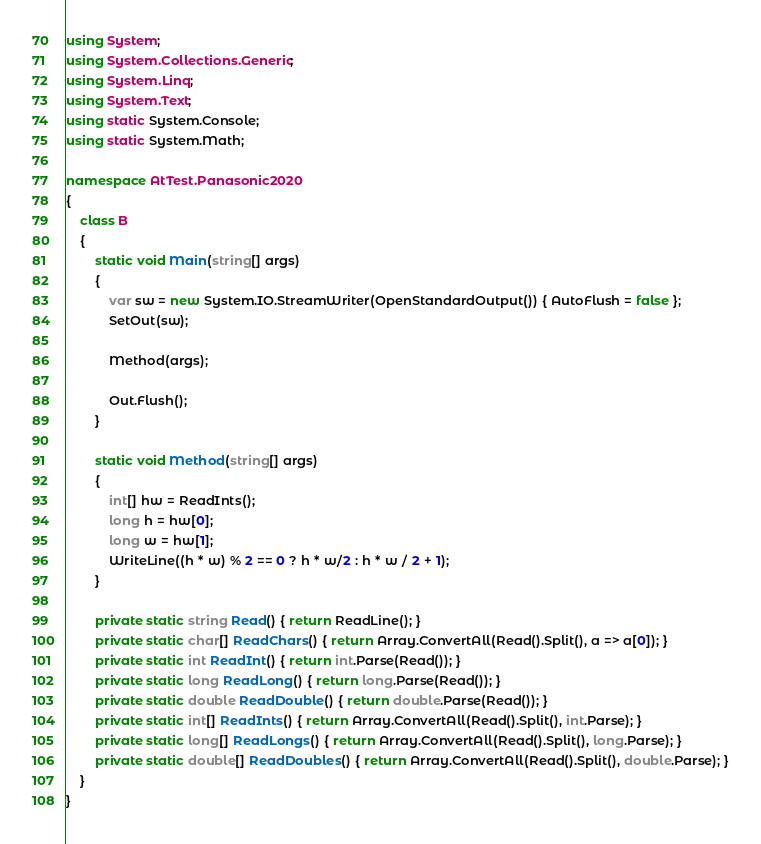<code> <loc_0><loc_0><loc_500><loc_500><_C#_>using System;
using System.Collections.Generic;
using System.Linq;
using System.Text;
using static System.Console;
using static System.Math;

namespace AtTest.Panasonic2020
{
    class B
    {
        static void Main(string[] args)
        {
            var sw = new System.IO.StreamWriter(OpenStandardOutput()) { AutoFlush = false };
            SetOut(sw);

            Method(args);

            Out.Flush();
        }

        static void Method(string[] args)
        {
            int[] hw = ReadInts();
            long h = hw[0];
            long w = hw[1];
            WriteLine((h * w) % 2 == 0 ? h * w/2 : h * w / 2 + 1);
        }

        private static string Read() { return ReadLine(); }
        private static char[] ReadChars() { return Array.ConvertAll(Read().Split(), a => a[0]); }
        private static int ReadInt() { return int.Parse(Read()); }
        private static long ReadLong() { return long.Parse(Read()); }
        private static double ReadDouble() { return double.Parse(Read()); }
        private static int[] ReadInts() { return Array.ConvertAll(Read().Split(), int.Parse); }
        private static long[] ReadLongs() { return Array.ConvertAll(Read().Split(), long.Parse); }
        private static double[] ReadDoubles() { return Array.ConvertAll(Read().Split(), double.Parse); }
    }
}
</code> 